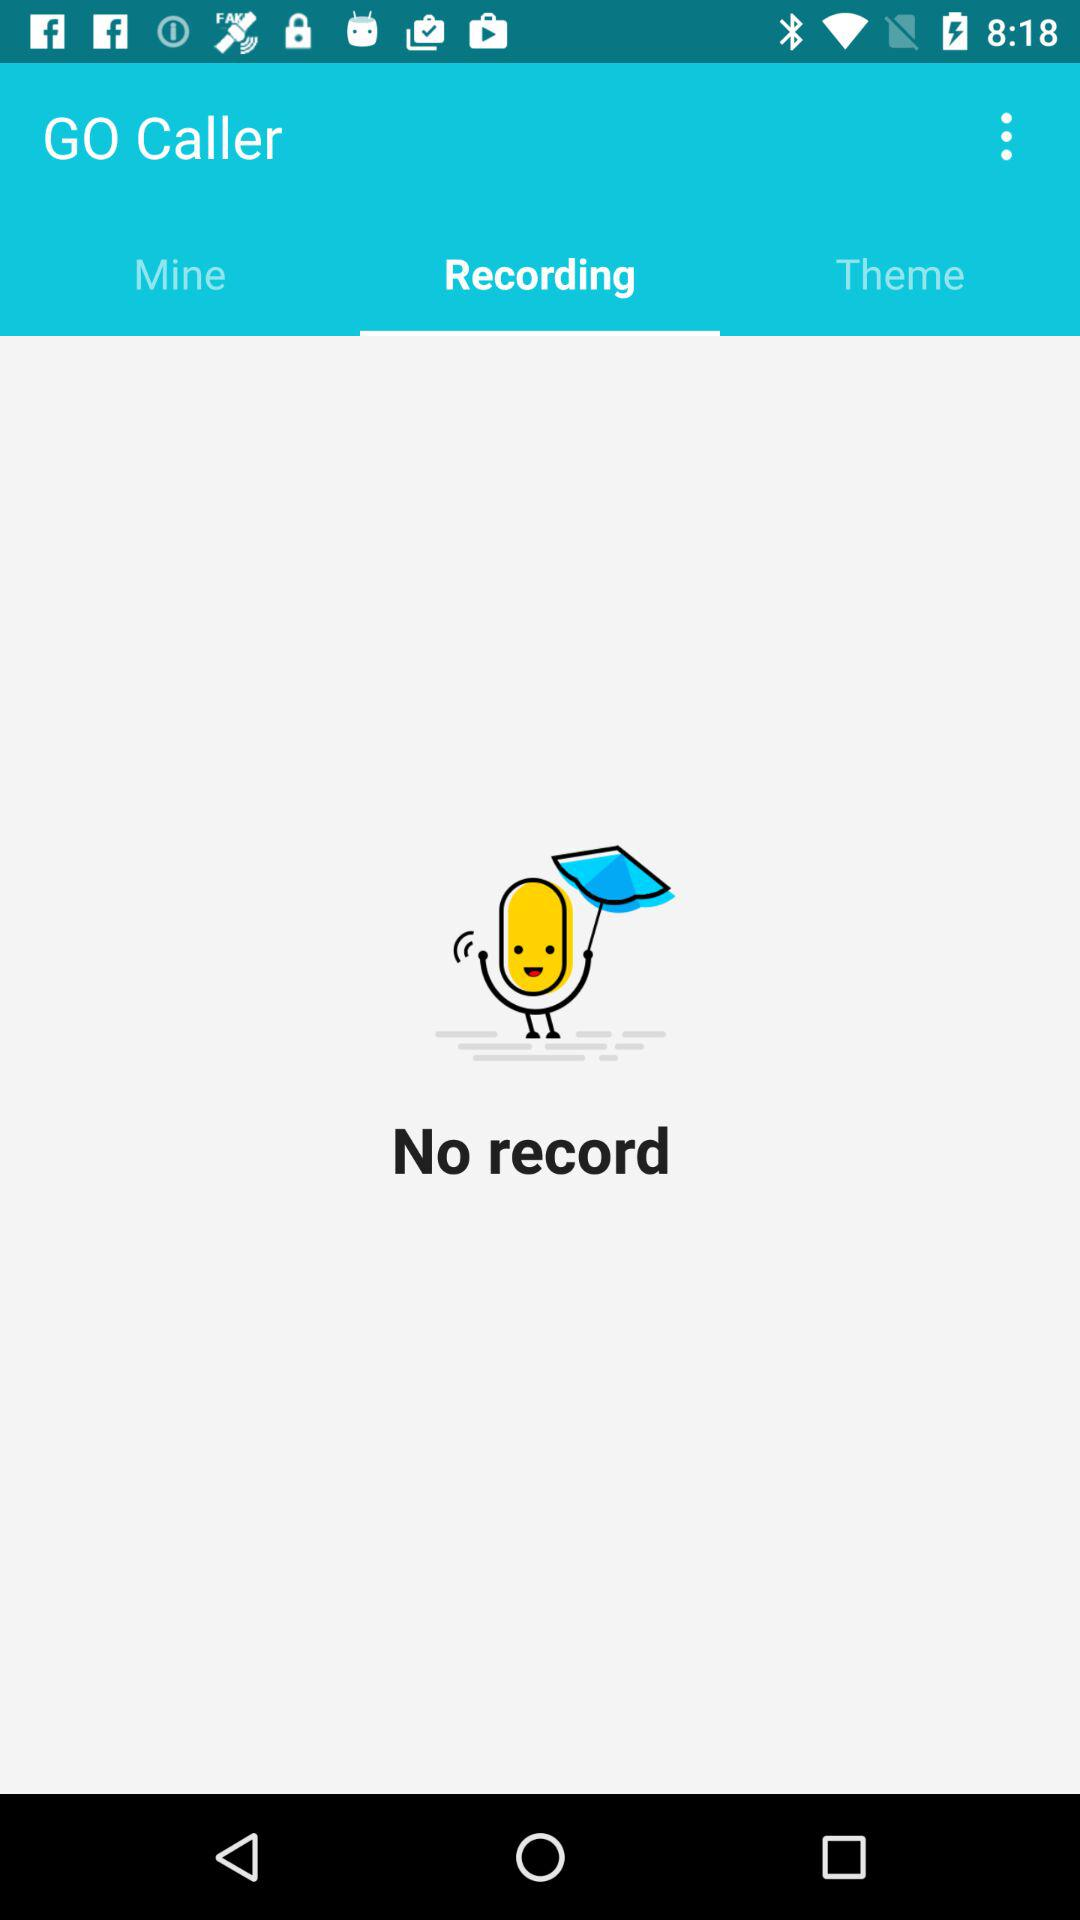Which tab is selected? The selected tab is "Recording". 